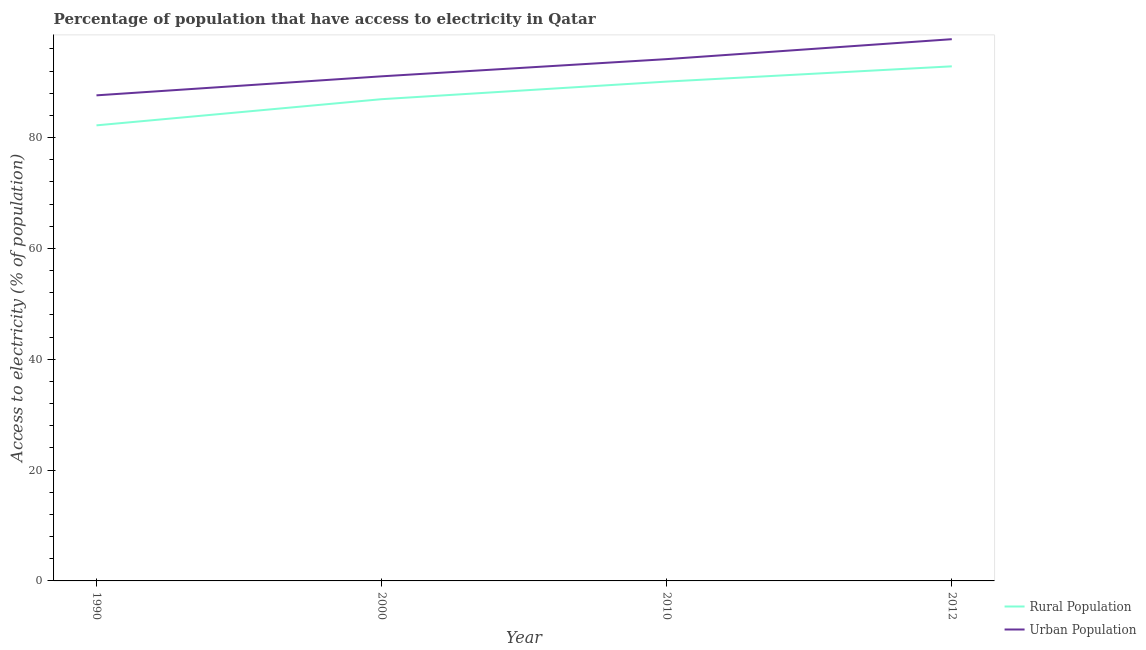How many different coloured lines are there?
Provide a short and direct response. 2. What is the percentage of rural population having access to electricity in 1990?
Provide a short and direct response. 82.2. Across all years, what is the maximum percentage of urban population having access to electricity?
Provide a short and direct response. 97.75. Across all years, what is the minimum percentage of rural population having access to electricity?
Provide a succinct answer. 82.2. In which year was the percentage of rural population having access to electricity maximum?
Your answer should be compact. 2012. In which year was the percentage of rural population having access to electricity minimum?
Provide a short and direct response. 1990. What is the total percentage of urban population having access to electricity in the graph?
Your answer should be very brief. 370.58. What is the difference between the percentage of rural population having access to electricity in 1990 and that in 2012?
Ensure brevity in your answer.  -10.65. What is the difference between the percentage of rural population having access to electricity in 1990 and the percentage of urban population having access to electricity in 2000?
Make the answer very short. -8.85. What is the average percentage of urban population having access to electricity per year?
Give a very brief answer. 92.64. In the year 2000, what is the difference between the percentage of rural population having access to electricity and percentage of urban population having access to electricity?
Keep it short and to the point. -4.13. In how many years, is the percentage of urban population having access to electricity greater than 20 %?
Your response must be concise. 4. What is the ratio of the percentage of urban population having access to electricity in 2010 to that in 2012?
Provide a succinct answer. 0.96. Is the percentage of urban population having access to electricity in 1990 less than that in 2012?
Provide a short and direct response. Yes. Is the difference between the percentage of urban population having access to electricity in 1990 and 2012 greater than the difference between the percentage of rural population having access to electricity in 1990 and 2012?
Your answer should be very brief. Yes. What is the difference between the highest and the second highest percentage of urban population having access to electricity?
Your answer should be very brief. 3.6. What is the difference between the highest and the lowest percentage of urban population having access to electricity?
Ensure brevity in your answer.  10.13. In how many years, is the percentage of urban population having access to electricity greater than the average percentage of urban population having access to electricity taken over all years?
Keep it short and to the point. 2. Does the percentage of rural population having access to electricity monotonically increase over the years?
Provide a short and direct response. Yes. Is the percentage of urban population having access to electricity strictly greater than the percentage of rural population having access to electricity over the years?
Your answer should be very brief. Yes. How many years are there in the graph?
Ensure brevity in your answer.  4. Does the graph contain any zero values?
Ensure brevity in your answer.  No. Does the graph contain grids?
Offer a terse response. No. How many legend labels are there?
Provide a short and direct response. 2. What is the title of the graph?
Give a very brief answer. Percentage of population that have access to electricity in Qatar. Does "Merchandise exports" appear as one of the legend labels in the graph?
Your answer should be compact. No. What is the label or title of the Y-axis?
Provide a short and direct response. Access to electricity (% of population). What is the Access to electricity (% of population) of Rural Population in 1990?
Your answer should be compact. 82.2. What is the Access to electricity (% of population) of Urban Population in 1990?
Provide a succinct answer. 87.62. What is the Access to electricity (% of population) in Rural Population in 2000?
Provide a succinct answer. 86.93. What is the Access to electricity (% of population) in Urban Population in 2000?
Offer a terse response. 91.05. What is the Access to electricity (% of population) of Rural Population in 2010?
Ensure brevity in your answer.  90.1. What is the Access to electricity (% of population) of Urban Population in 2010?
Your response must be concise. 94.15. What is the Access to electricity (% of population) of Rural Population in 2012?
Make the answer very short. 92.85. What is the Access to electricity (% of population) of Urban Population in 2012?
Keep it short and to the point. 97.75. Across all years, what is the maximum Access to electricity (% of population) in Rural Population?
Your answer should be compact. 92.85. Across all years, what is the maximum Access to electricity (% of population) of Urban Population?
Give a very brief answer. 97.75. Across all years, what is the minimum Access to electricity (% of population) of Rural Population?
Give a very brief answer. 82.2. Across all years, what is the minimum Access to electricity (% of population) in Urban Population?
Provide a succinct answer. 87.62. What is the total Access to electricity (% of population) in Rural Population in the graph?
Ensure brevity in your answer.  352.08. What is the total Access to electricity (% of population) of Urban Population in the graph?
Offer a terse response. 370.58. What is the difference between the Access to electricity (% of population) in Rural Population in 1990 and that in 2000?
Your response must be concise. -4.72. What is the difference between the Access to electricity (% of population) of Urban Population in 1990 and that in 2000?
Ensure brevity in your answer.  -3.43. What is the difference between the Access to electricity (% of population) of Rural Population in 1990 and that in 2010?
Make the answer very short. -7.9. What is the difference between the Access to electricity (% of population) in Urban Population in 1990 and that in 2010?
Keep it short and to the point. -6.54. What is the difference between the Access to electricity (% of population) of Rural Population in 1990 and that in 2012?
Provide a short and direct response. -10.65. What is the difference between the Access to electricity (% of population) in Urban Population in 1990 and that in 2012?
Provide a short and direct response. -10.13. What is the difference between the Access to electricity (% of population) of Rural Population in 2000 and that in 2010?
Ensure brevity in your answer.  -3.17. What is the difference between the Access to electricity (% of population) of Urban Population in 2000 and that in 2010?
Keep it short and to the point. -3.1. What is the difference between the Access to electricity (% of population) in Rural Population in 2000 and that in 2012?
Provide a succinct answer. -5.93. What is the difference between the Access to electricity (% of population) in Urban Population in 2000 and that in 2012?
Provide a succinct answer. -6.7. What is the difference between the Access to electricity (% of population) of Rural Population in 2010 and that in 2012?
Offer a very short reply. -2.75. What is the difference between the Access to electricity (% of population) of Urban Population in 2010 and that in 2012?
Offer a very short reply. -3.6. What is the difference between the Access to electricity (% of population) of Rural Population in 1990 and the Access to electricity (% of population) of Urban Population in 2000?
Your response must be concise. -8.85. What is the difference between the Access to electricity (% of population) in Rural Population in 1990 and the Access to electricity (% of population) in Urban Population in 2010?
Offer a terse response. -11.95. What is the difference between the Access to electricity (% of population) of Rural Population in 1990 and the Access to electricity (% of population) of Urban Population in 2012?
Offer a very short reply. -15.55. What is the difference between the Access to electricity (% of population) of Rural Population in 2000 and the Access to electricity (% of population) of Urban Population in 2010?
Provide a succinct answer. -7.23. What is the difference between the Access to electricity (% of population) in Rural Population in 2000 and the Access to electricity (% of population) in Urban Population in 2012?
Give a very brief answer. -10.83. What is the difference between the Access to electricity (% of population) of Rural Population in 2010 and the Access to electricity (% of population) of Urban Population in 2012?
Offer a very short reply. -7.65. What is the average Access to electricity (% of population) in Rural Population per year?
Offer a terse response. 88.02. What is the average Access to electricity (% of population) in Urban Population per year?
Keep it short and to the point. 92.64. In the year 1990, what is the difference between the Access to electricity (% of population) of Rural Population and Access to electricity (% of population) of Urban Population?
Keep it short and to the point. -5.42. In the year 2000, what is the difference between the Access to electricity (% of population) of Rural Population and Access to electricity (% of population) of Urban Population?
Ensure brevity in your answer.  -4.13. In the year 2010, what is the difference between the Access to electricity (% of population) of Rural Population and Access to electricity (% of population) of Urban Population?
Provide a succinct answer. -4.05. In the year 2012, what is the difference between the Access to electricity (% of population) of Rural Population and Access to electricity (% of population) of Urban Population?
Give a very brief answer. -4.9. What is the ratio of the Access to electricity (% of population) of Rural Population in 1990 to that in 2000?
Offer a very short reply. 0.95. What is the ratio of the Access to electricity (% of population) in Urban Population in 1990 to that in 2000?
Provide a short and direct response. 0.96. What is the ratio of the Access to electricity (% of population) in Rural Population in 1990 to that in 2010?
Offer a very short reply. 0.91. What is the ratio of the Access to electricity (% of population) of Urban Population in 1990 to that in 2010?
Provide a short and direct response. 0.93. What is the ratio of the Access to electricity (% of population) of Rural Population in 1990 to that in 2012?
Keep it short and to the point. 0.89. What is the ratio of the Access to electricity (% of population) in Urban Population in 1990 to that in 2012?
Give a very brief answer. 0.9. What is the ratio of the Access to electricity (% of population) of Rural Population in 2000 to that in 2010?
Offer a very short reply. 0.96. What is the ratio of the Access to electricity (% of population) in Urban Population in 2000 to that in 2010?
Your answer should be compact. 0.97. What is the ratio of the Access to electricity (% of population) of Rural Population in 2000 to that in 2012?
Provide a succinct answer. 0.94. What is the ratio of the Access to electricity (% of population) of Urban Population in 2000 to that in 2012?
Keep it short and to the point. 0.93. What is the ratio of the Access to electricity (% of population) in Rural Population in 2010 to that in 2012?
Ensure brevity in your answer.  0.97. What is the ratio of the Access to electricity (% of population) of Urban Population in 2010 to that in 2012?
Your response must be concise. 0.96. What is the difference between the highest and the second highest Access to electricity (% of population) of Rural Population?
Keep it short and to the point. 2.75. What is the difference between the highest and the second highest Access to electricity (% of population) of Urban Population?
Give a very brief answer. 3.6. What is the difference between the highest and the lowest Access to electricity (% of population) of Rural Population?
Your answer should be very brief. 10.65. What is the difference between the highest and the lowest Access to electricity (% of population) of Urban Population?
Ensure brevity in your answer.  10.13. 